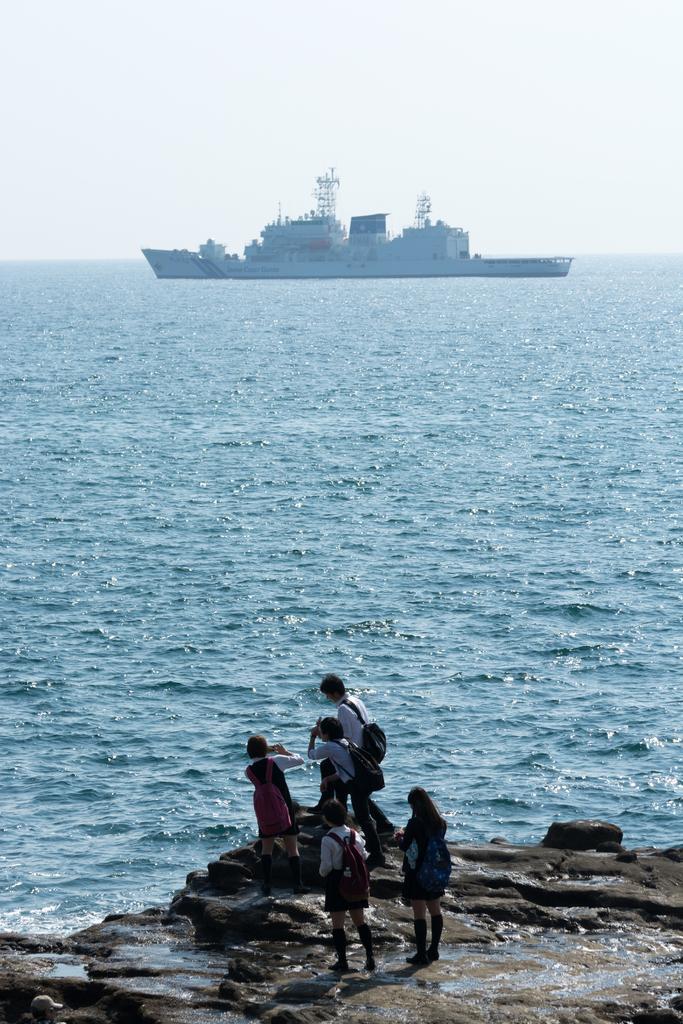In one or two sentences, can you explain what this image depicts? In this picture we can see some people are standing in the front, we can see water at the bottom, there is a ship in the water, we can see the sky at the top of the picture. 